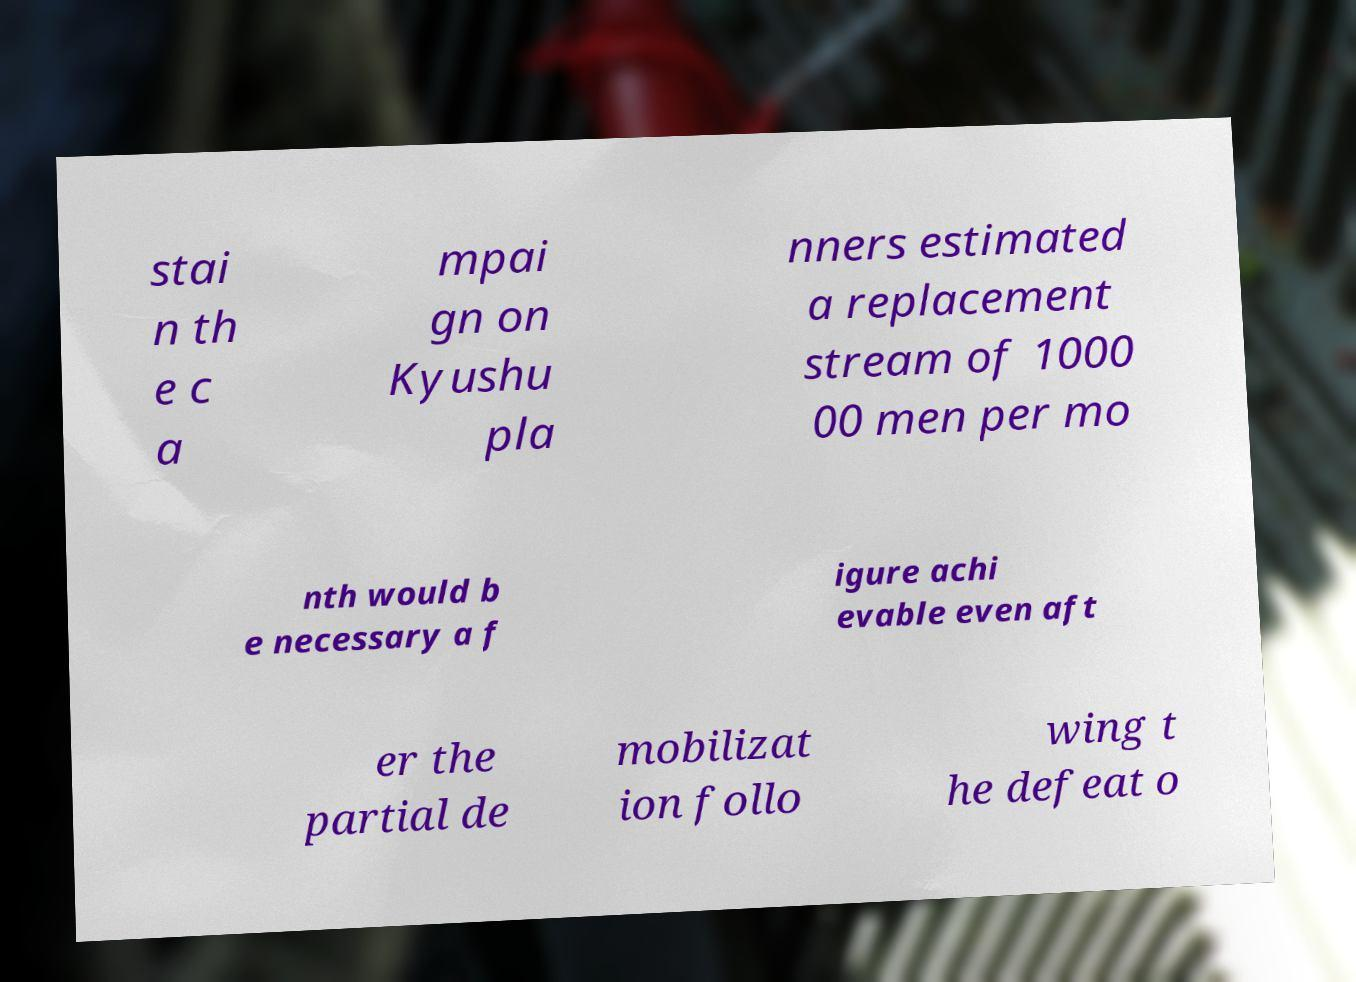Could you assist in decoding the text presented in this image and type it out clearly? stai n th e c a mpai gn on Kyushu pla nners estimated a replacement stream of 1000 00 men per mo nth would b e necessary a f igure achi evable even aft er the partial de mobilizat ion follo wing t he defeat o 